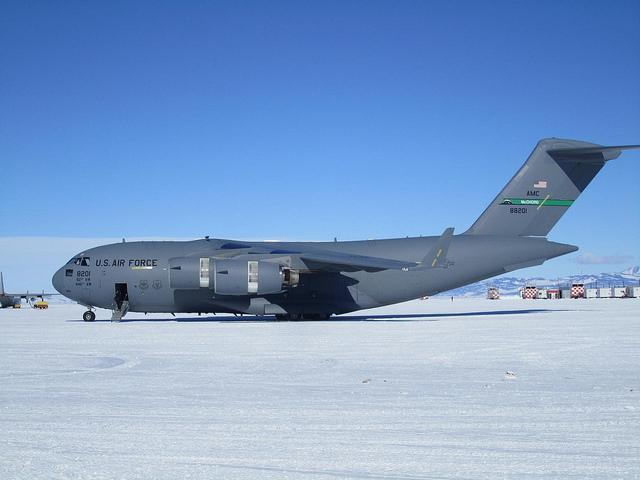What is written on the plane?
Concise answer only. Us air force. Is that a military plane?
Keep it brief. Yes. Is this arctic or desert?
Give a very brief answer. Arctic. 